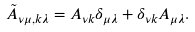Convert formula to latex. <formula><loc_0><loc_0><loc_500><loc_500>\tilde { A } _ { \nu \mu , k \lambda } = A _ { \nu k } \delta _ { \mu \lambda } + \delta _ { \nu k } A _ { \mu \lambda } .</formula> 